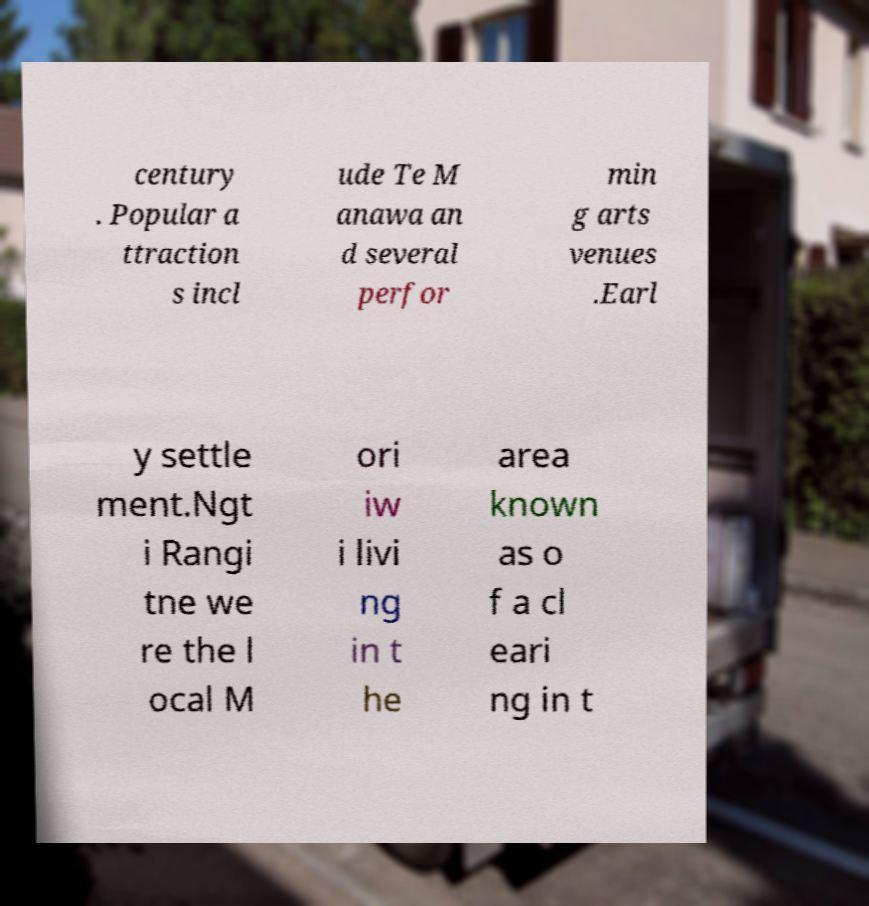I need the written content from this picture converted into text. Can you do that? century . Popular a ttraction s incl ude Te M anawa an d several perfor min g arts venues .Earl y settle ment.Ngt i Rangi tne we re the l ocal M ori iw i livi ng in t he area known as o f a cl eari ng in t 